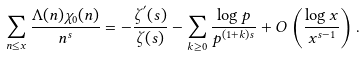Convert formula to latex. <formula><loc_0><loc_0><loc_500><loc_500>\sum _ { n \leq x } \frac { \Lambda ( n ) \chi _ { 0 } ( n ) } { n ^ { s } } = - \frac { \zeta ^ { ^ { \prime } } ( s ) } { \zeta ( s ) } - \sum _ { k \geq 0 } \frac { \log p } { p ^ { ( 1 + k ) s } } + O \left ( \frac { \log x } { x ^ { s - 1 } } \right ) .</formula> 